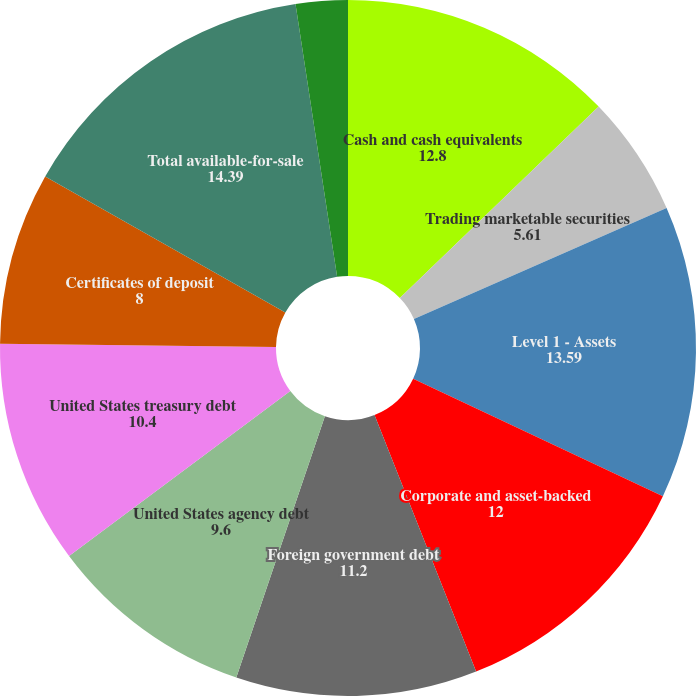Convert chart to OTSL. <chart><loc_0><loc_0><loc_500><loc_500><pie_chart><fcel>Cash and cash equivalents<fcel>Trading marketable securities<fcel>Level 1 - Assets<fcel>Corporate and asset-backed<fcel>Foreign government debt<fcel>United States agency debt<fcel>United States treasury debt<fcel>Certificates of deposit<fcel>Total available-for-sale<fcel>Foreign currency exchange<nl><fcel>12.8%<fcel>5.61%<fcel>13.59%<fcel>12.0%<fcel>11.2%<fcel>9.6%<fcel>10.4%<fcel>8.0%<fcel>14.39%<fcel>2.41%<nl></chart> 